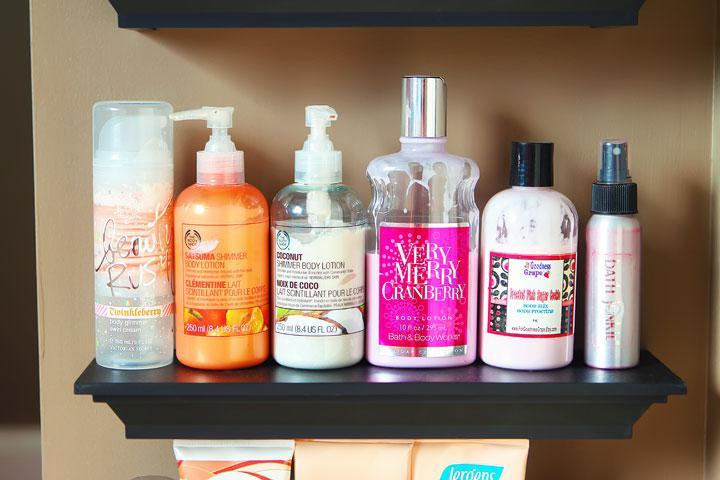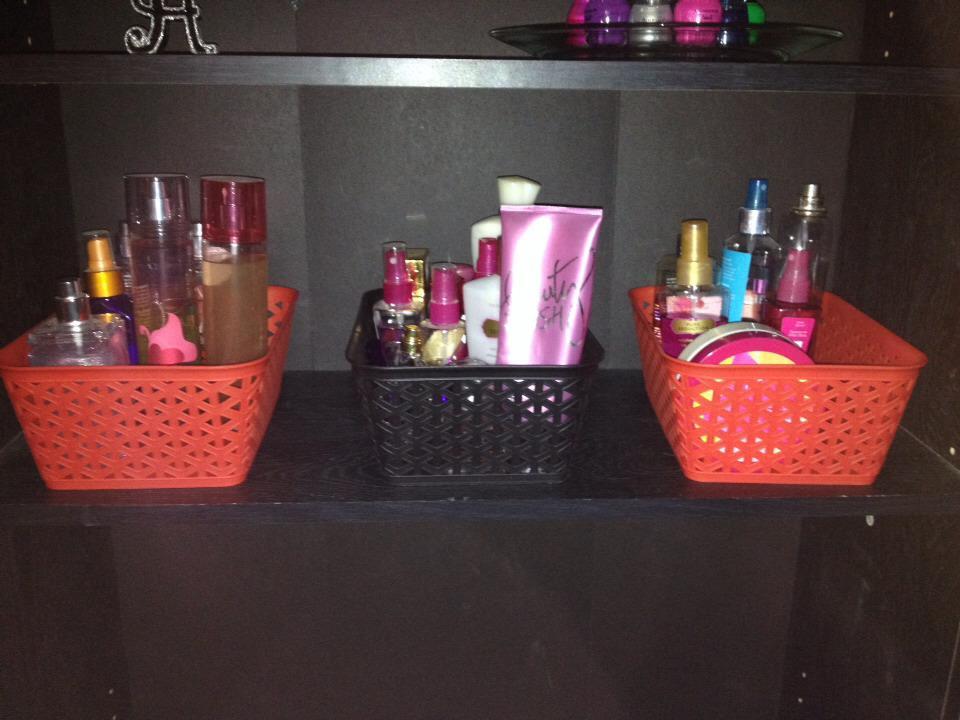The first image is the image on the left, the second image is the image on the right. Given the left and right images, does the statement "An image shows one black shelf holding a row of six beauty products." hold true? Answer yes or no. Yes. 